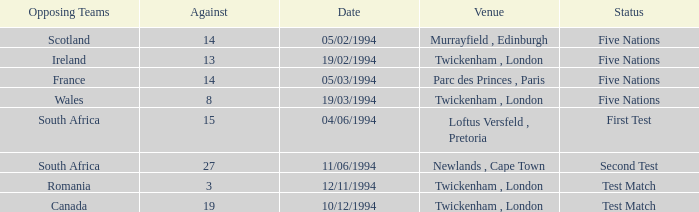How many against have a status of first test? 1.0. 